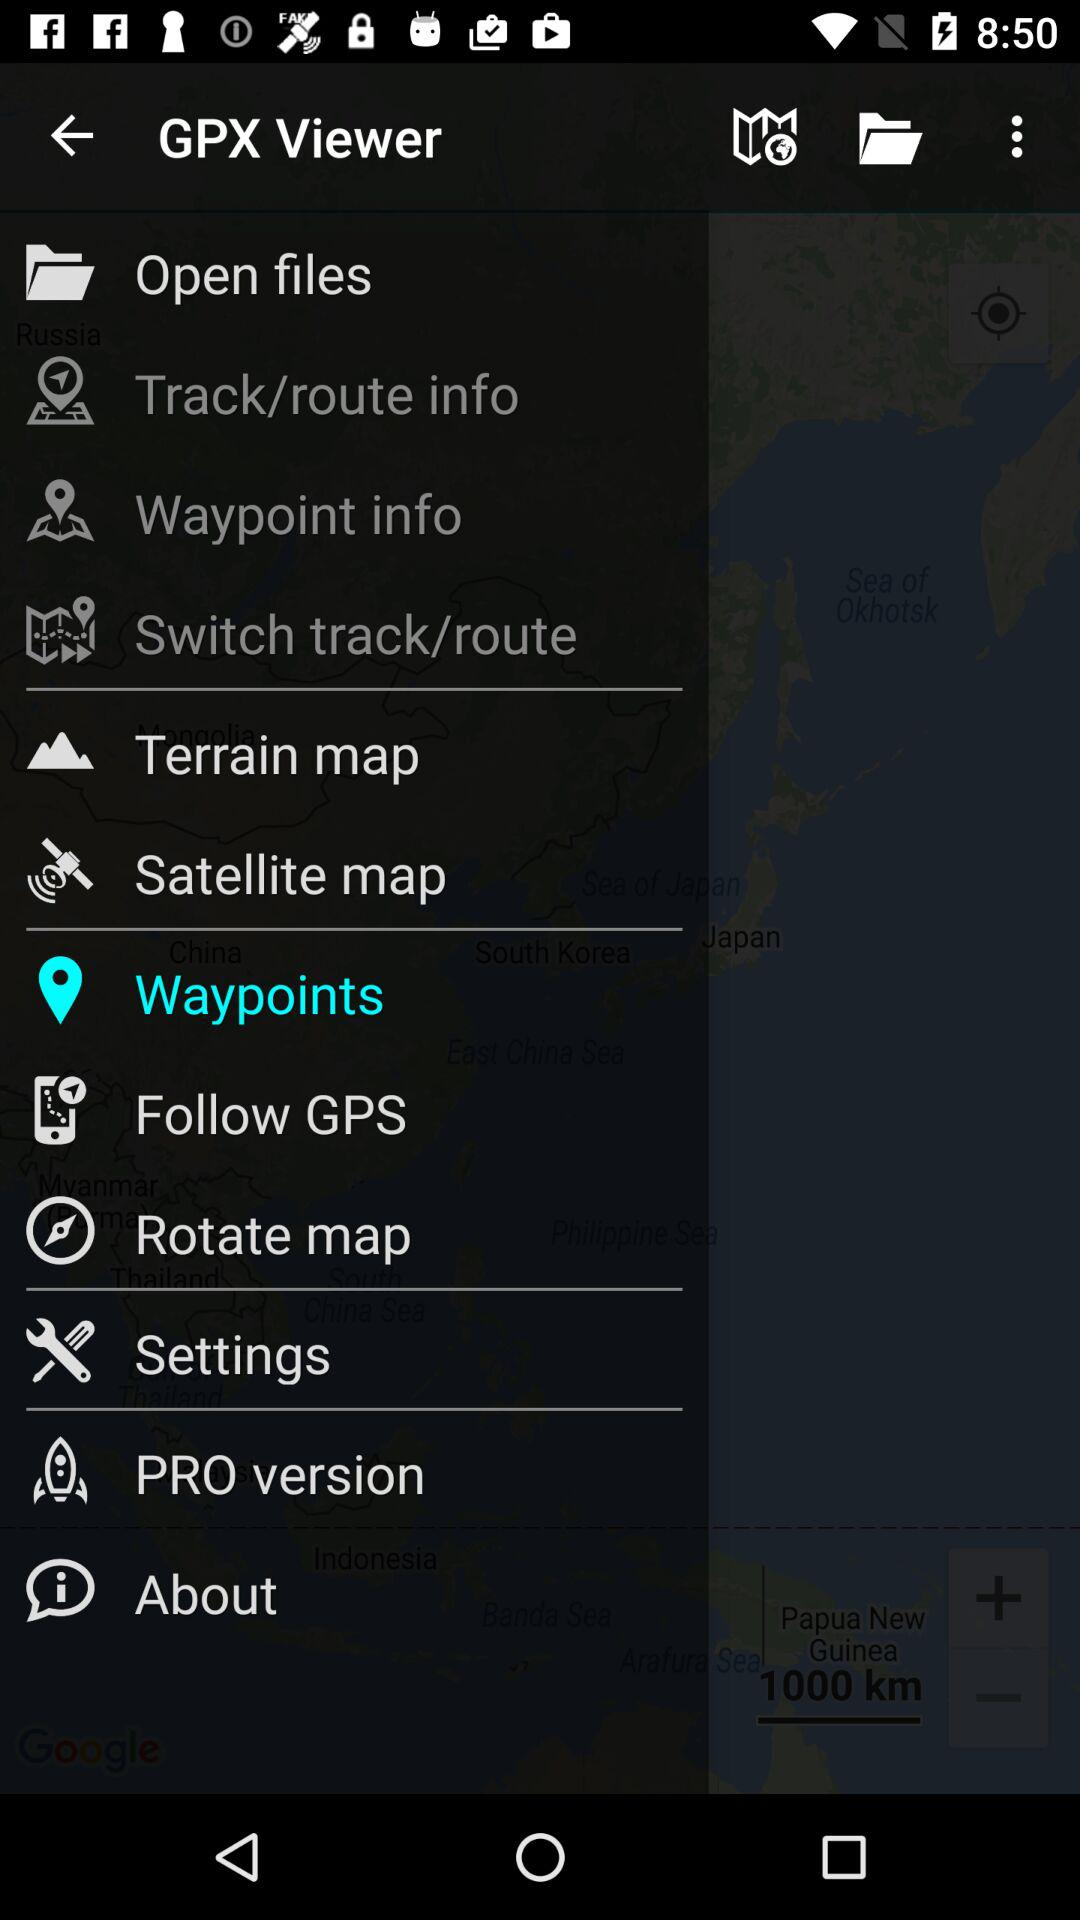What is the application name? The application name is "GPX Viewer". 